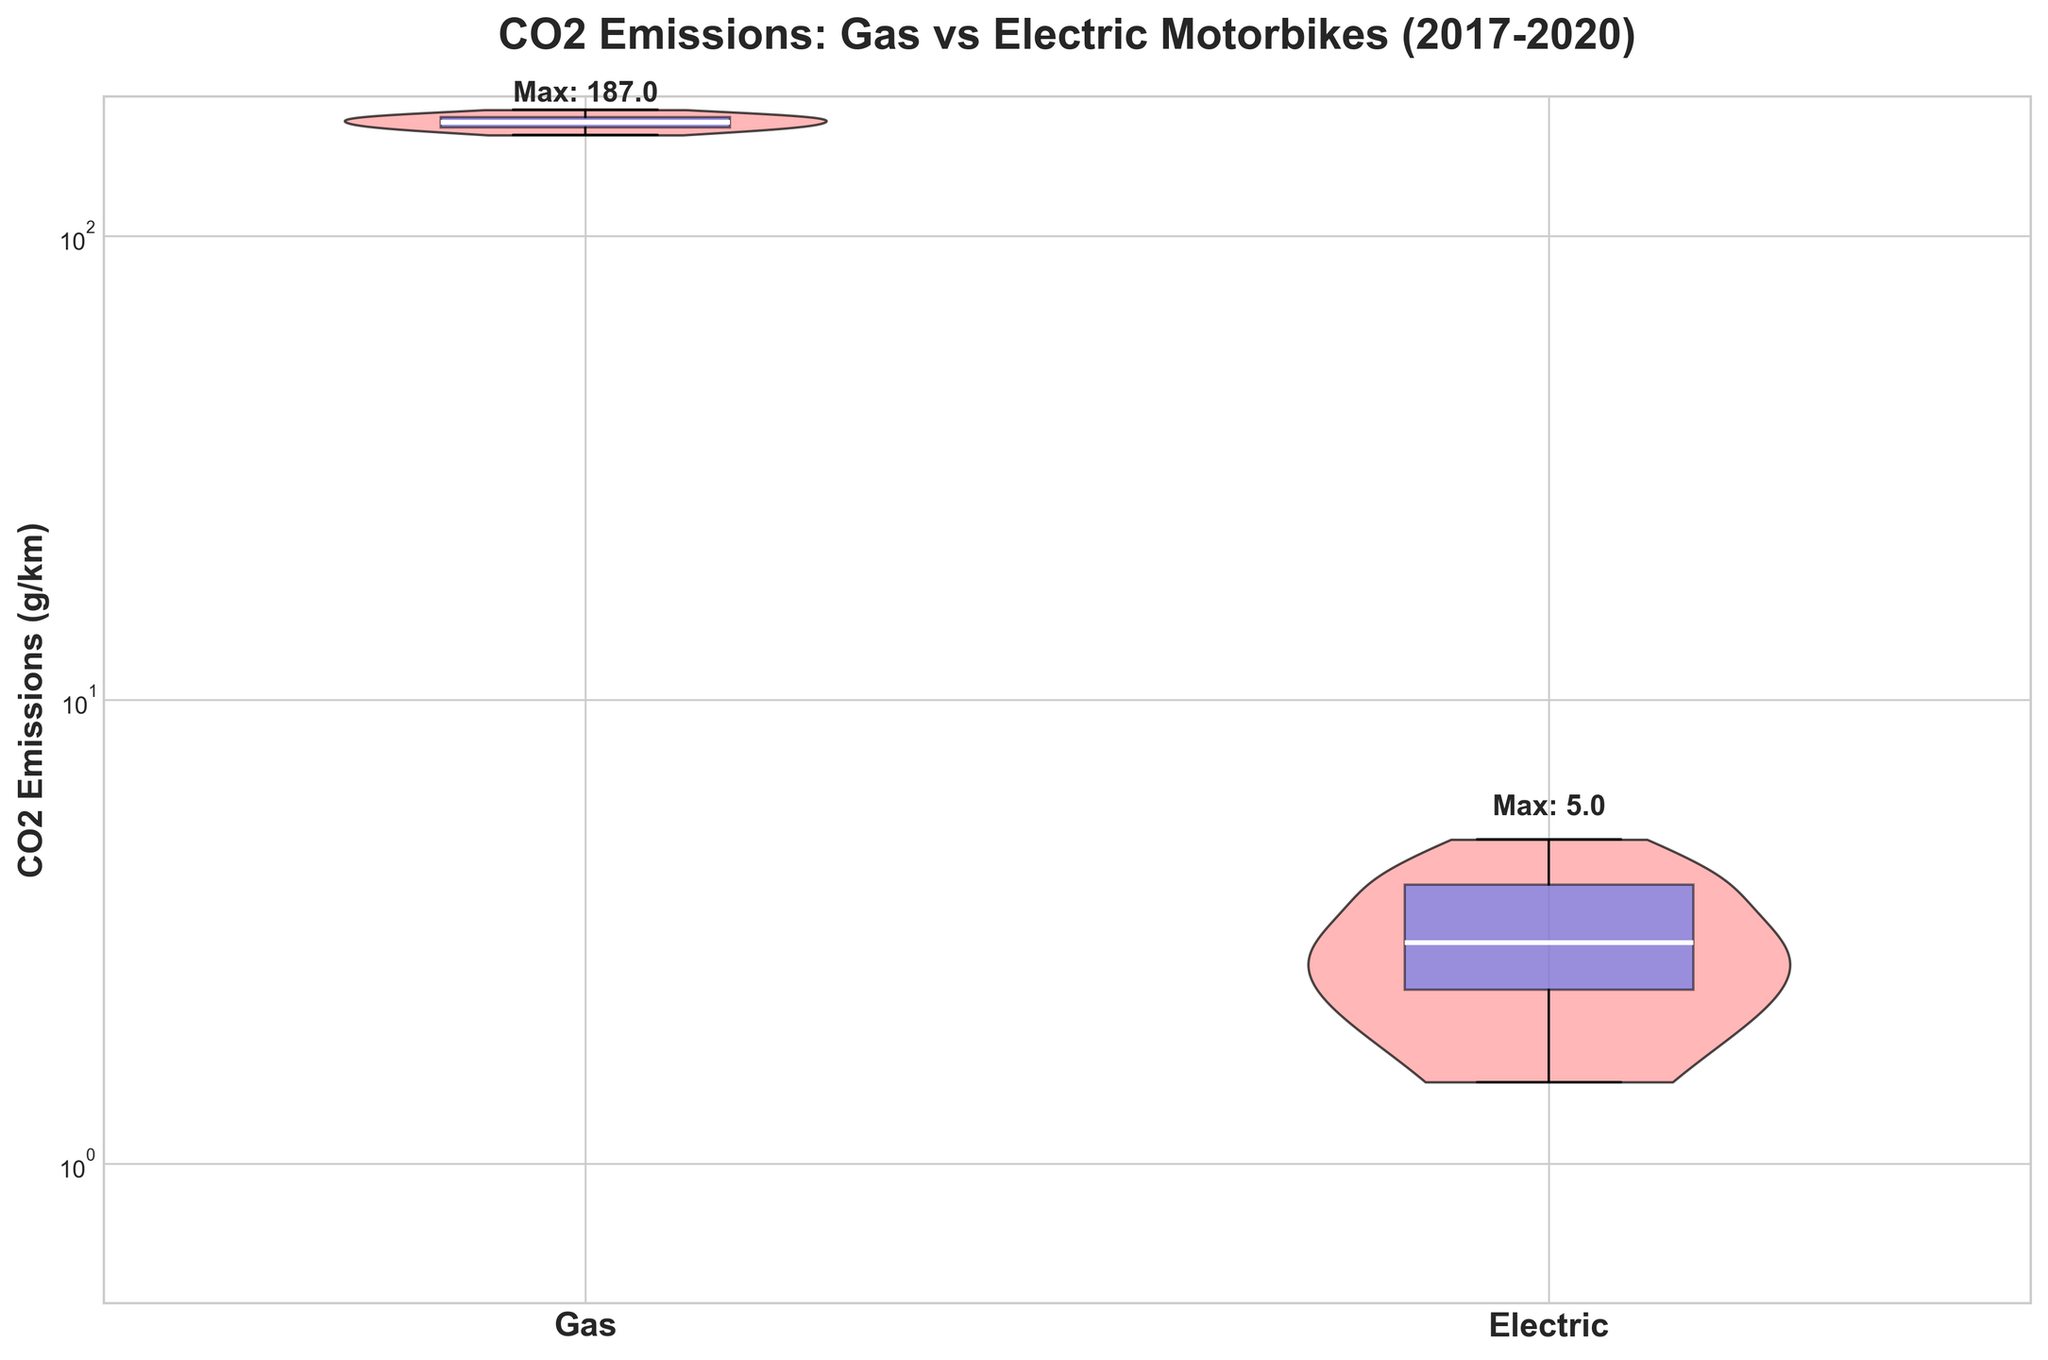What is the title of the figure? The title is the text at the top of the figure that summarizes what the plot is about. It helps readers quickly understand the main focus of the visualization.
Answer: CO2 Emissions: Gas vs Electric Motorbikes (2017-2020) What are the two categories compared in the figure? The x-axis labels indicate the categories of motorbikes being compared. Looking at the labels on the x-axis, we see two distinct groups.
Answer: Gas and Electric Which type of motorbike has a higher maximum CO2 emission value? Examine the annotations above the violin plots which display the maximum value for each motorbike type. The 'Max' text indicates the highest CO2 emission within the dataset for each group.
Answer: Gas What is the scale of the y-axis? The y-axis is labeled on the left side of the plot. Noticing its increments and annotations, we can determine its type.
Answer: Logarithmic scale What is the relative position of the median lines in the boxplots for gas and electric motorbikes? Observe the white median lines within the blue boxes of each violin plot. Compare their vertical positions to determine their relative values.
Answer: The median line of the gas motorbikes is higher than that of the electric motorbikes Which motorbike type has more spread in their CO2 emissions? Analyze the width and height of the violins, which represent the distribution of data points. Wider and taller violins indicate a larger spread of values.
Answer: Gas What is the maximum CO2 emission value for electric motorbikes? Look at the annotation text above the violin plot for electric motorbikes, which specifies the highest emission value in the dataset for this category.
Answer: 5.5 g/km How does the variability of CO2 emissions compare between gas and electric motorbikes? Assess the shape and width of the violin plots for both gas and electric motorbikes. A wider and taller violin indicates higher variability. Compare these attributes between the two categories.
Answer: Gas motorbikes have higher variability Between 2017 and 2020, did the CO2 emissions for gas motorbikes decrease? Refer to the chronological data points within the violin plot. A decrease over time would be indicated by lower positions of the data distributions for gas motorbikes in the later years compared to the earlier ones.
Answer: Yes Why might the figure use a logarithmic scale on the y-axis? A logarithmic scale is useful when comparing data that has a large range of values because it can present both small and large values more clearly. This is especially relevant when comparing emissions that span several orders of magnitude.
Answer: To clearly present a large range of values 